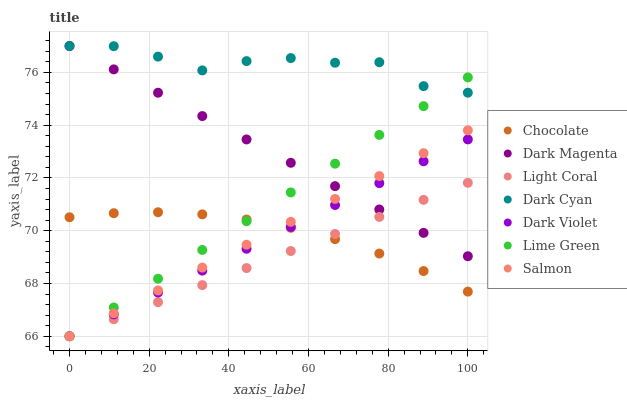Does Light Coral have the minimum area under the curve?
Answer yes or no. Yes. Does Dark Cyan have the maximum area under the curve?
Answer yes or no. Yes. Does Salmon have the minimum area under the curve?
Answer yes or no. No. Does Salmon have the maximum area under the curve?
Answer yes or no. No. Is Lime Green the smoothest?
Answer yes or no. Yes. Is Dark Cyan the roughest?
Answer yes or no. Yes. Is Salmon the smoothest?
Answer yes or no. No. Is Salmon the roughest?
Answer yes or no. No. Does Salmon have the lowest value?
Answer yes or no. Yes. Does Chocolate have the lowest value?
Answer yes or no. No. Does Dark Cyan have the highest value?
Answer yes or no. Yes. Does Salmon have the highest value?
Answer yes or no. No. Is Salmon less than Dark Cyan?
Answer yes or no. Yes. Is Dark Cyan greater than Chocolate?
Answer yes or no. Yes. Does Lime Green intersect Salmon?
Answer yes or no. Yes. Is Lime Green less than Salmon?
Answer yes or no. No. Is Lime Green greater than Salmon?
Answer yes or no. No. Does Salmon intersect Dark Cyan?
Answer yes or no. No. 